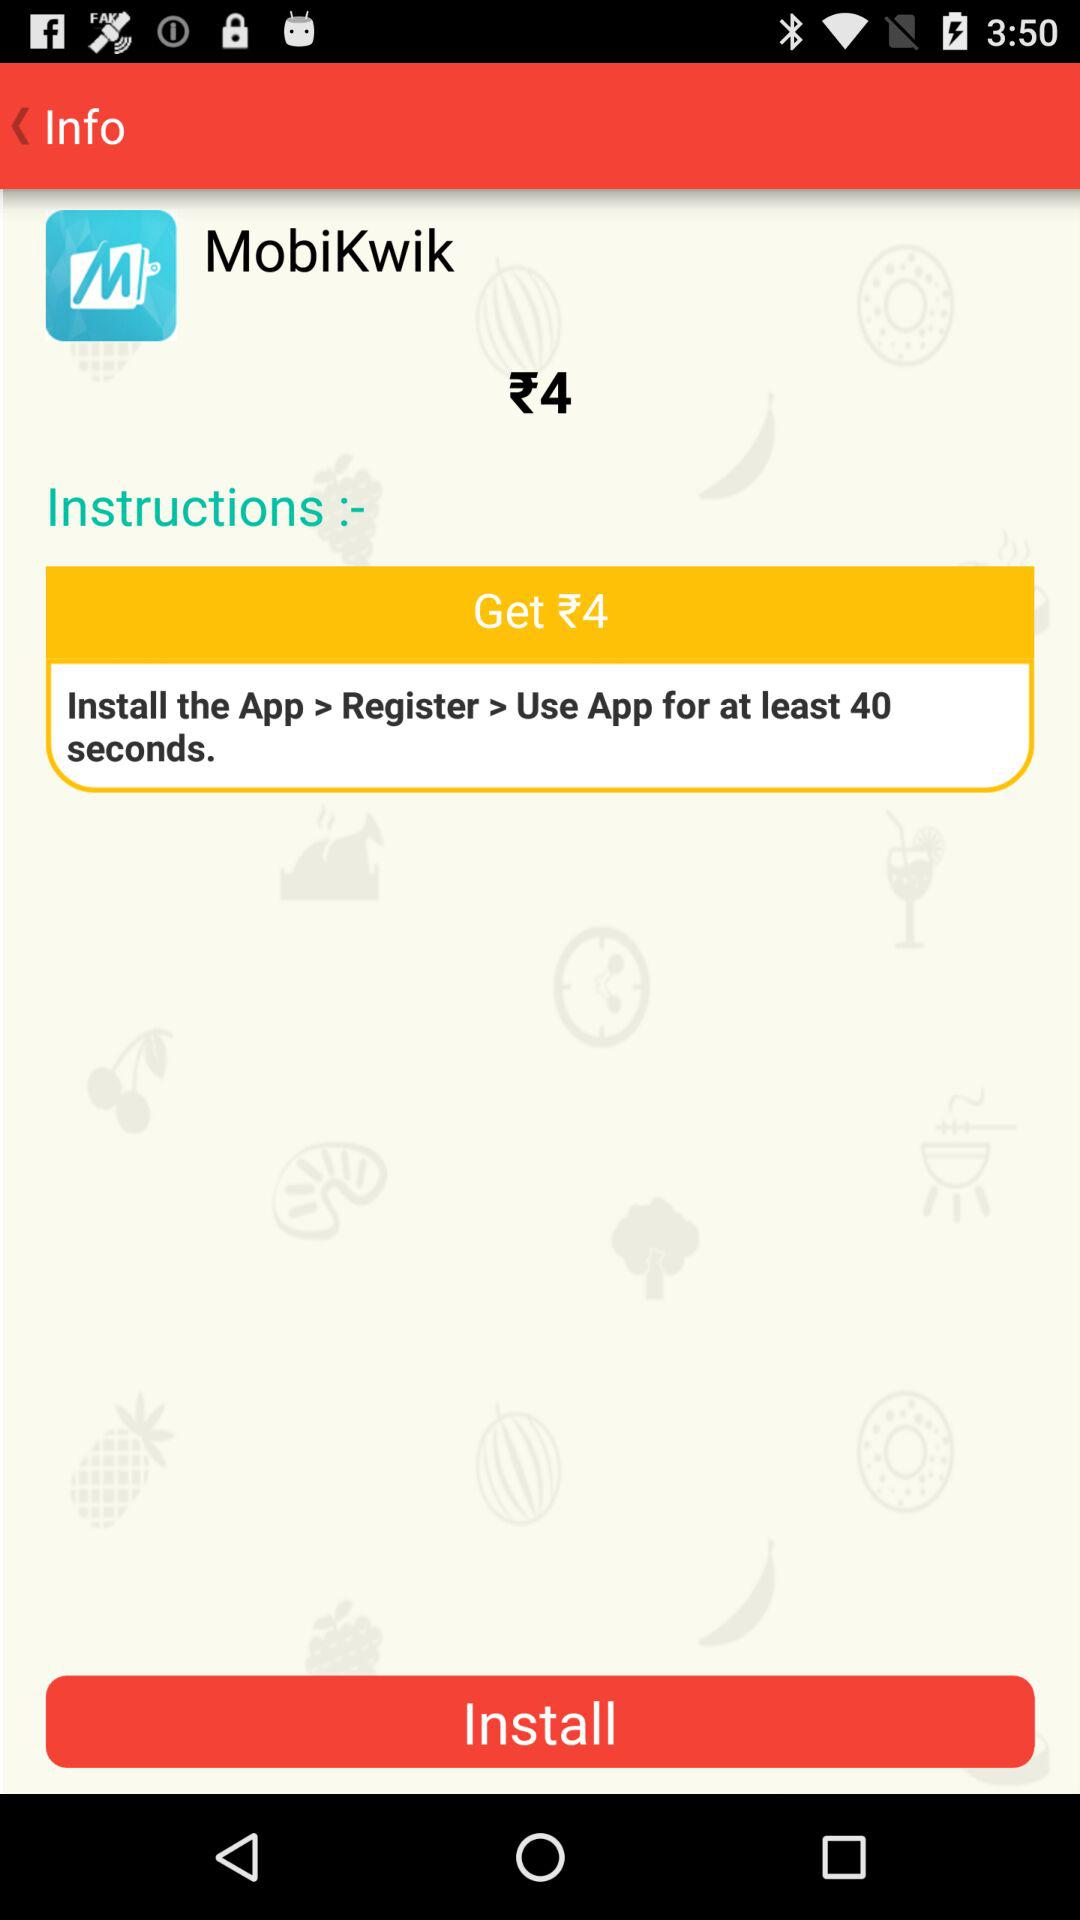What price will I get for using this application for 40 seconds? You will get ₹4. 